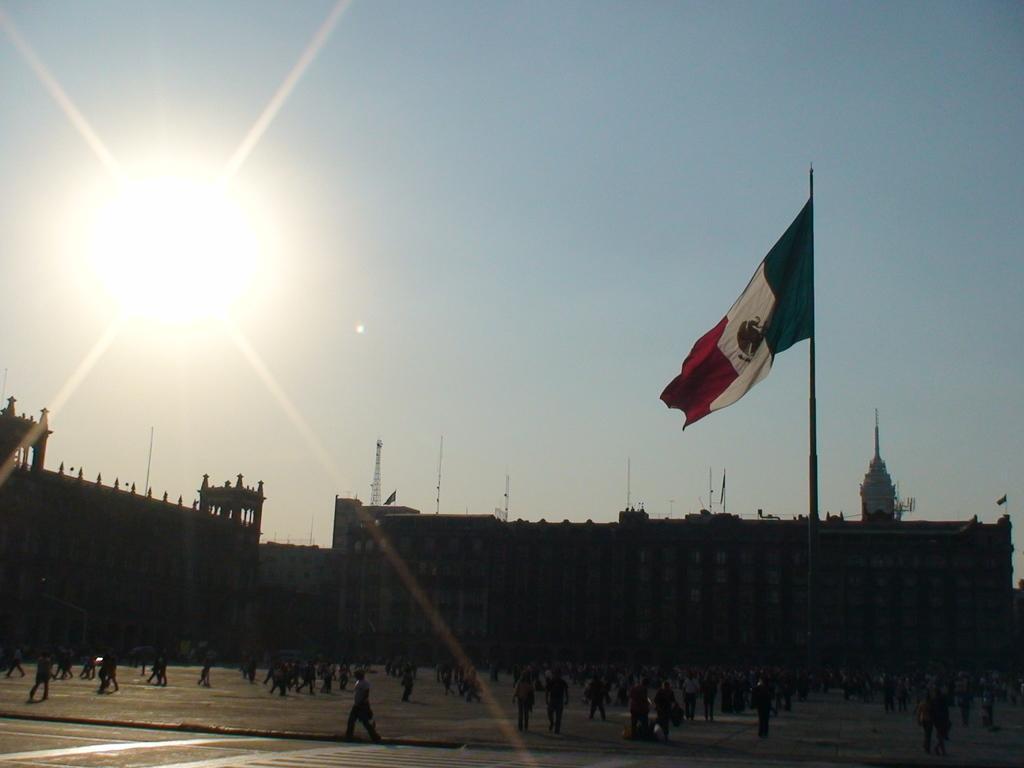Please provide a concise description of this image. In this image there are so many people who are walking on the floor. In the middle there is a flag. In the background there are buildings. On the buildings there are towers. At the top there is sunlight. 